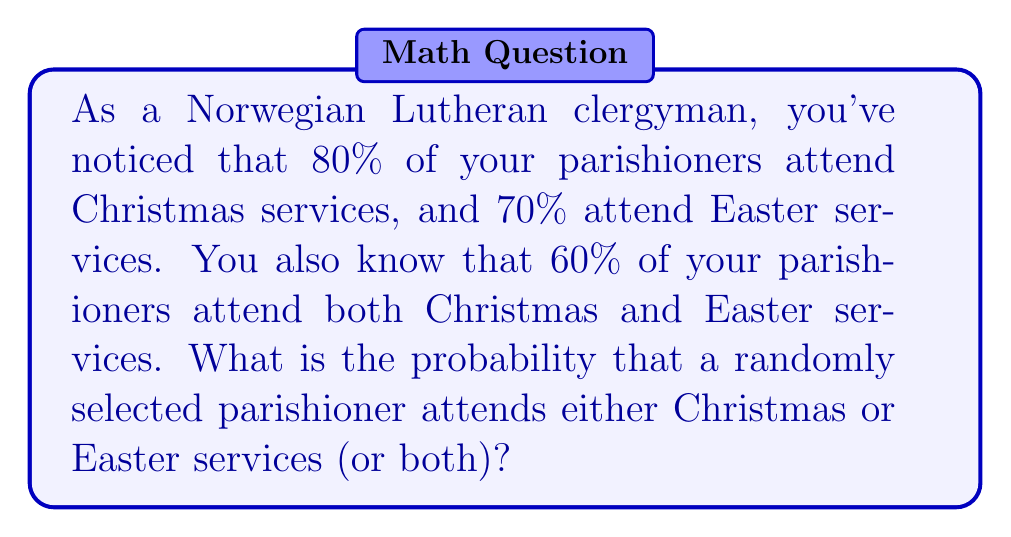Teach me how to tackle this problem. To solve this problem, we'll use the concept of probability addition for non-mutually exclusive events. Let's define our events:

$A$: The event that a parishioner attends Christmas services
$B$: The event that a parishioner attends Easter services

We're given:
$P(A) = 0.80$
$P(B) = 0.70$
$P(A \cap B) = 0.60$

The formula for the probability of either event occurring (or both) is:

$$P(A \cup B) = P(A) + P(B) - P(A \cap B)$$

This formula accounts for the overlap between the two events to avoid double-counting.

Substituting our values:

$$P(A \cup B) = 0.80 + 0.70 - 0.60$$

$$P(A \cup B) = 1.50 - 0.60$$

$$P(A \cup B) = 0.90$$

Therefore, the probability that a randomly selected parishioner attends either Christmas or Easter services (or both) is 0.90 or 90%.
Answer: $P(A \cup B) = 0.90$ or 90% 